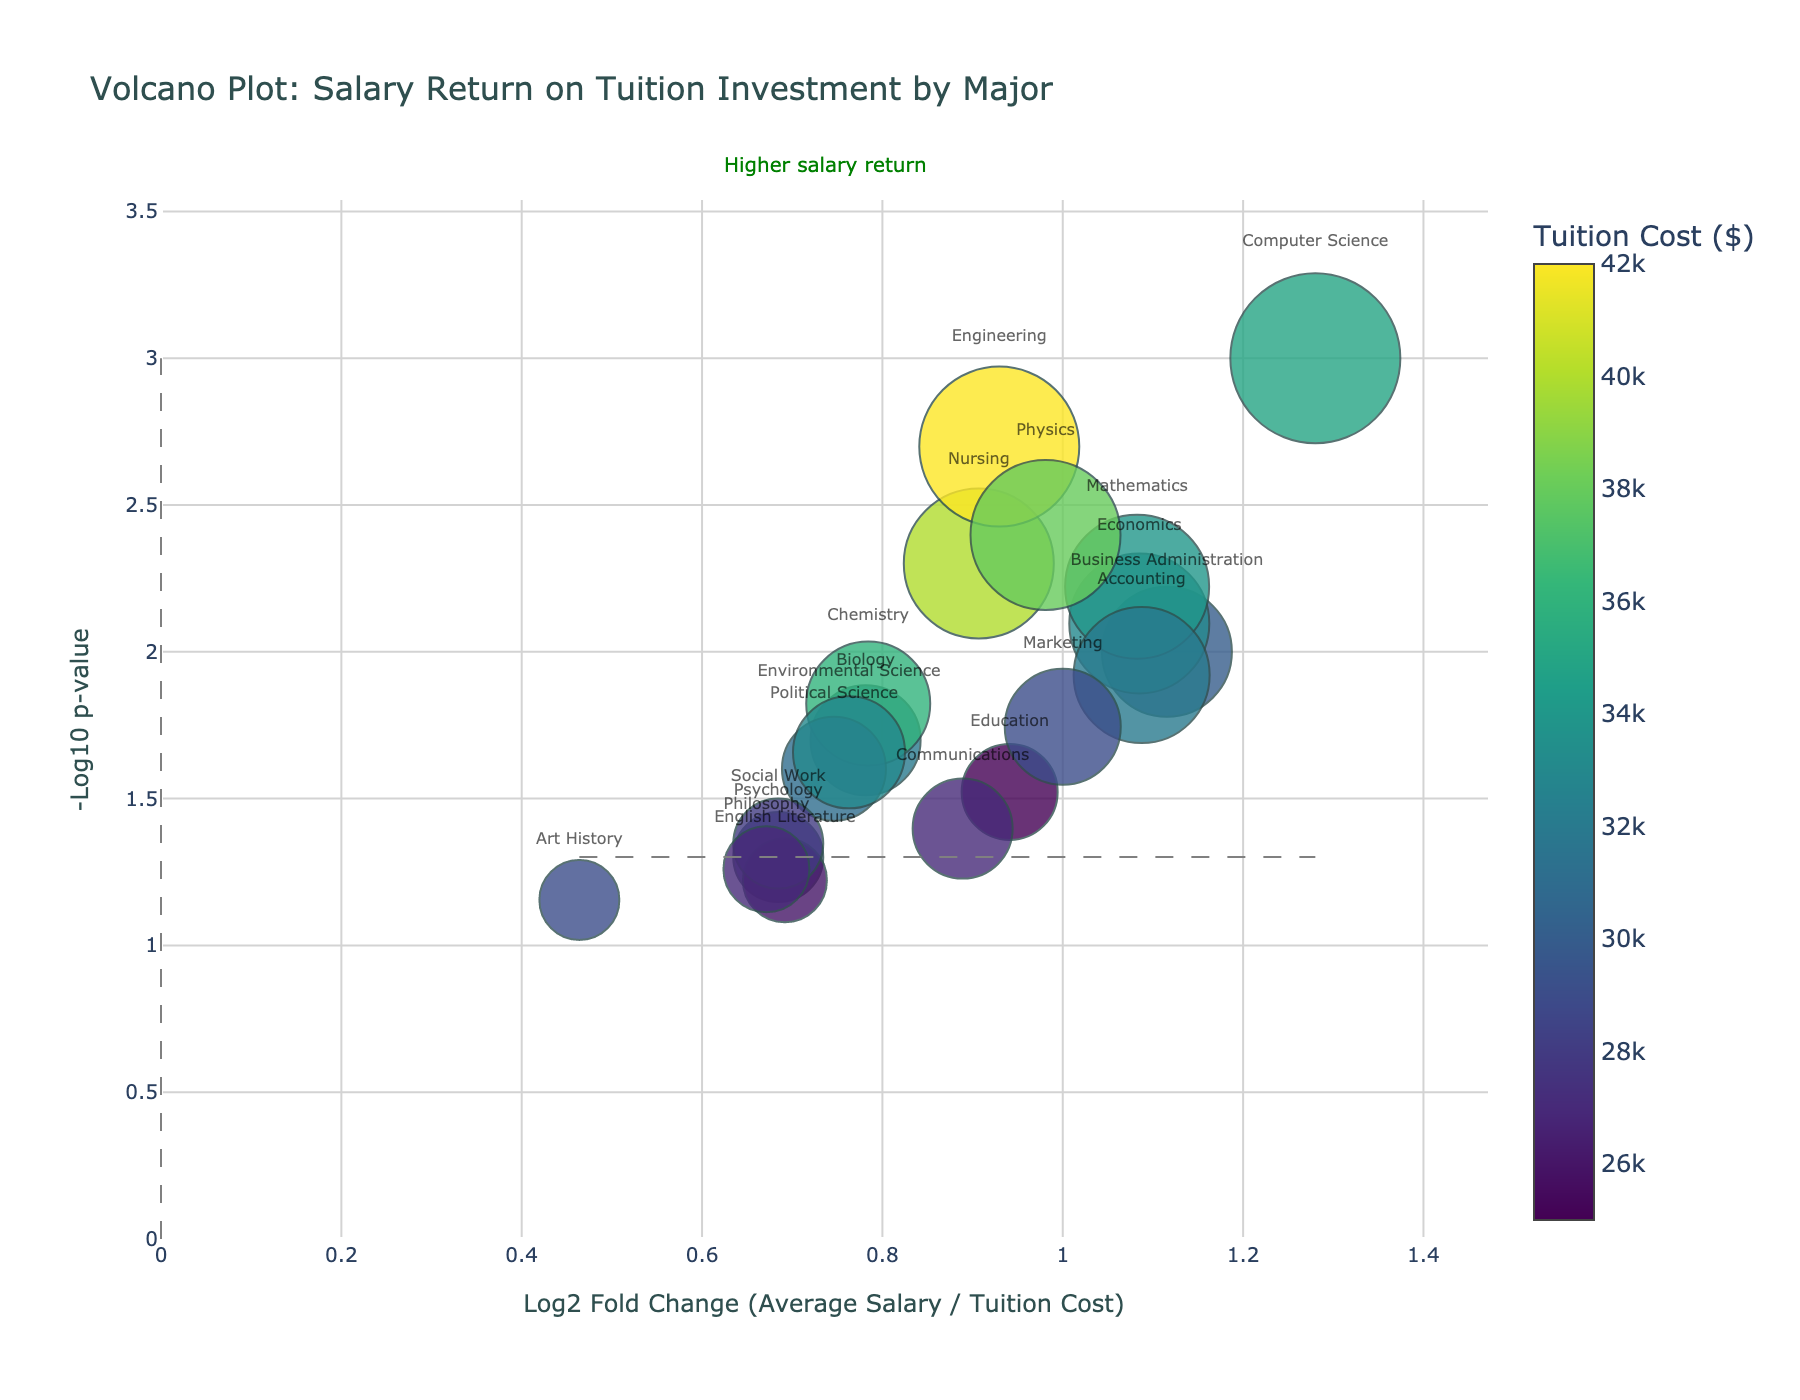How many majors are represented in the plot? Count each data point labeled with a major in the plot. There are 19 majors listed in the data, so there should be 19 points in the plot.
Answer: 19 Which major shows the highest salary return relative to its tuition cost? Look for the data point farthest to the right along the x-axis (log2 fold change axis). Computer Science has the highest positive log2 fold change, indicating the highest salary return relative to tuition cost.
Answer: Computer Science Are there any majors with higher p-values than the significance threshold? Identify data points below the horizontal line indicating the significance threshold (y-axis value around -log10(0.05)). Majors like Psychology and English Literature are below this line.
Answer: Yes Which major has the highest tuition cost and what is its average salary? Find the marker with the highest value on the color scale (which represents tuition cost). Engineering has the highest tuition cost, and its average salary is $80,000.
Answer: Engineering; $80,000 Which major has the lowest average salary, and what is its tuition cost? Identify the data point with the smallest marker size (indicating average salary). Art History has the lowest average salary of $40,000, and its tuition cost is $29,000.
Answer: Art History; $29,000 Which major has the highest log2 fold change but is above the significance threshold? Find the data point with the highest log2 fold change that is below the horizontal line of significance threshold. Mathematics has a high log2 fold change but is above the significance threshold (-log10 p-value greater than ~1.301).
Answer: Mathematics What is the general trend between tuition costs and log2 fold change? Observe the colors of the markers as you move along the x-axis. Higher tuition costs (darker colors) tend to have higher log2 fold changes (right of the plot).
Answer: Higher tuition costs generally correlate with higher log2 fold changes Which three majors are closest to the significance threshold line? Look at data points nearest the horizontal line at y = -log10(0.05). Psychology, Education, and Communications are near this threshold.
Answer: Psychology, Education, Communications What does a positive log2 fold change indicate in this plot? Interpret the axis labels and definitions. A positive log2 fold change indicates that the average salary is higher than the tuition cost.
Answer: Higher average salary than tuition cost Compare the average salaries of Engineering and Nursing, which major offers a better return relative to their tuition costs? Locate the positions of both majors on the plot. Engineering has a slightly lower average salary ($80,000) compared to Nursing ($75,000) but a better return (higher positive log2 fold change).
Answer: Engineering 